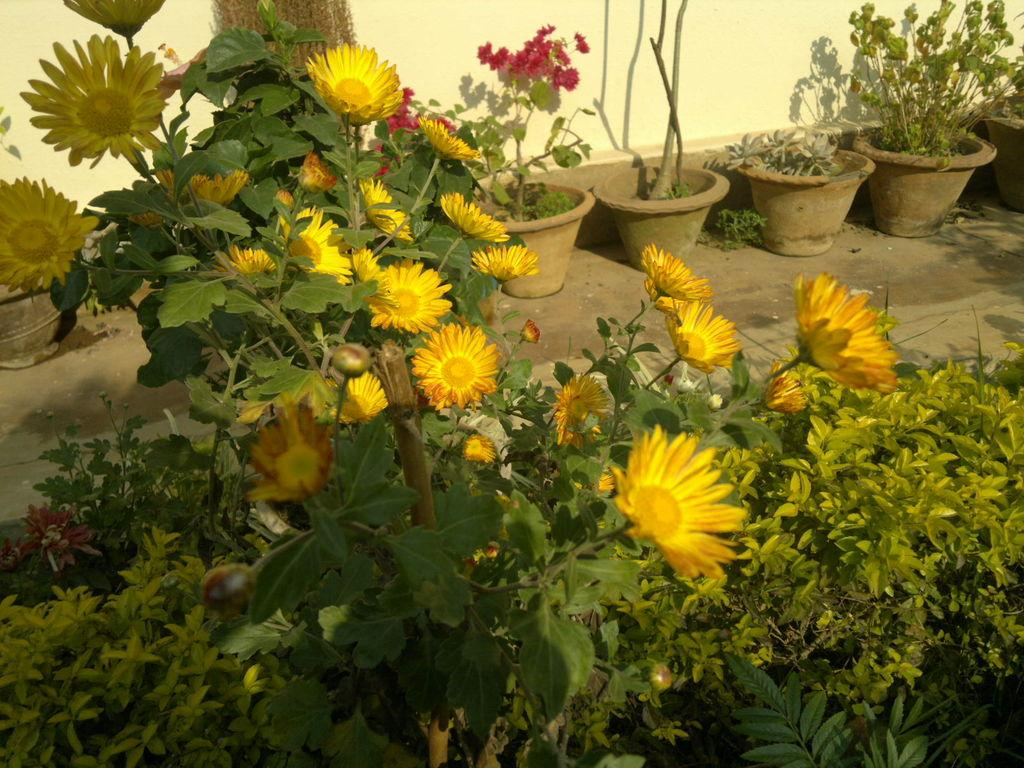What type of vegetation can be seen in the image? There are flowers, house plants, and trees in the image. Where are the house plants located in the image? The house plants are on the ground in the image. What can be seen in the background of the image? There is a wall visible in the background of the image. What is the topic of the discussion taking place among the flowers in the image? There is no discussion taking place among the flowers in the image, as they are inanimate objects. 